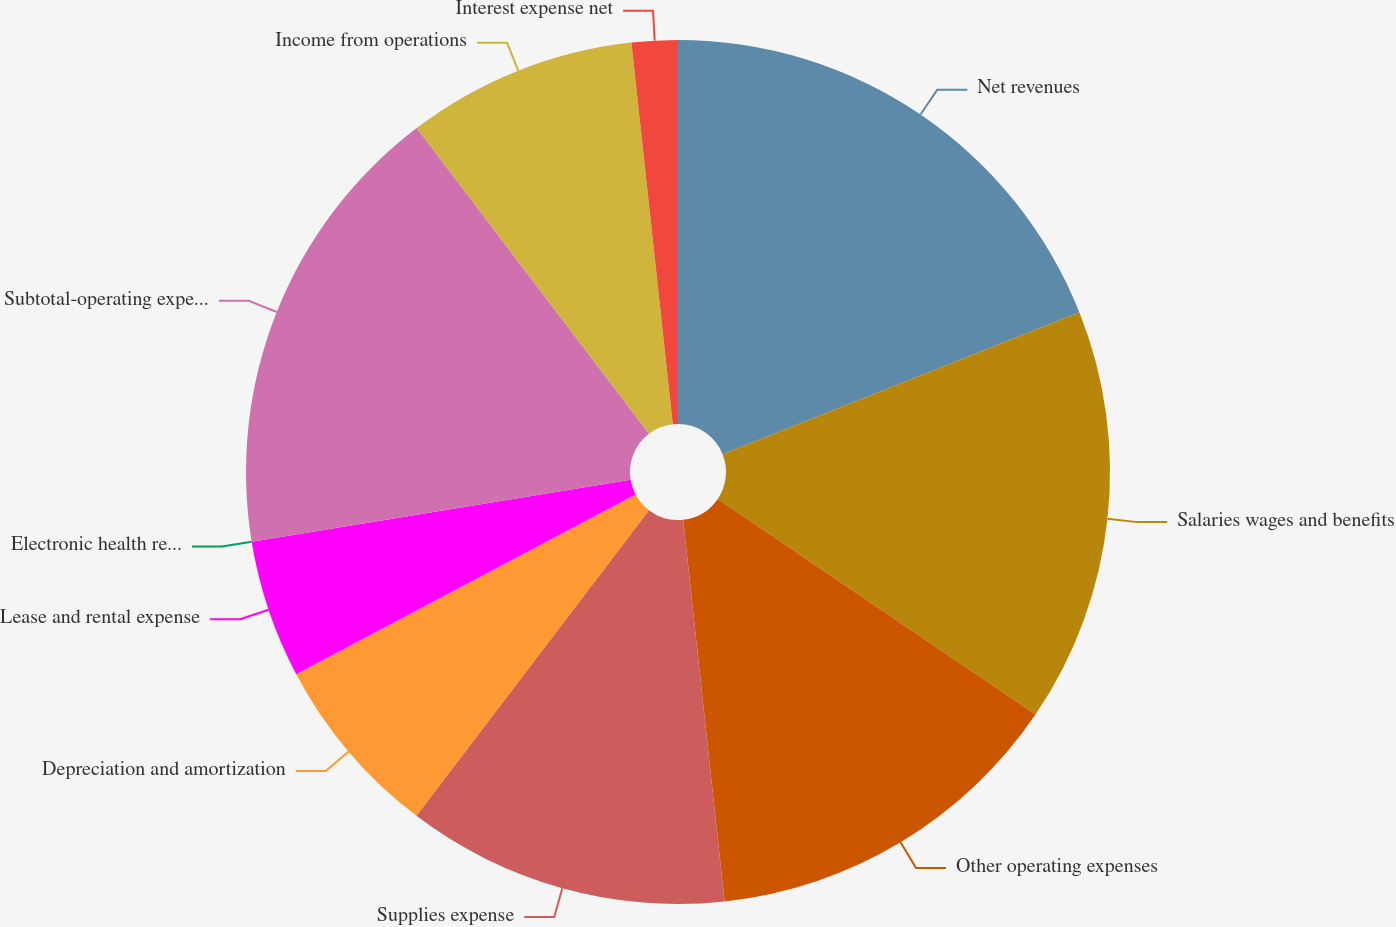Convert chart to OTSL. <chart><loc_0><loc_0><loc_500><loc_500><pie_chart><fcel>Net revenues<fcel>Salaries wages and benefits<fcel>Other operating expenses<fcel>Supplies expense<fcel>Depreciation and amortization<fcel>Lease and rental expense<fcel>Electronic health records<fcel>Subtotal-operating expenses<fcel>Income from operations<fcel>Interest expense net<nl><fcel>18.97%<fcel>15.52%<fcel>13.79%<fcel>12.07%<fcel>6.9%<fcel>5.17%<fcel>0.0%<fcel>17.24%<fcel>8.62%<fcel>1.72%<nl></chart> 